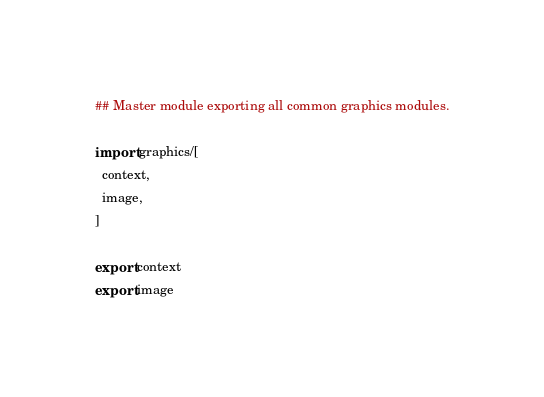Convert code to text. <code><loc_0><loc_0><loc_500><loc_500><_Nim_>## Master module exporting all common graphics modules.

import graphics/[
  context,
  image,
]

export context
export image
</code> 